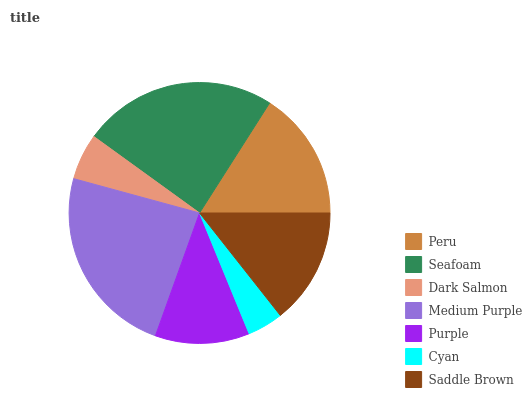Is Cyan the minimum?
Answer yes or no. Yes. Is Seafoam the maximum?
Answer yes or no. Yes. Is Dark Salmon the minimum?
Answer yes or no. No. Is Dark Salmon the maximum?
Answer yes or no. No. Is Seafoam greater than Dark Salmon?
Answer yes or no. Yes. Is Dark Salmon less than Seafoam?
Answer yes or no. Yes. Is Dark Salmon greater than Seafoam?
Answer yes or no. No. Is Seafoam less than Dark Salmon?
Answer yes or no. No. Is Saddle Brown the high median?
Answer yes or no. Yes. Is Saddle Brown the low median?
Answer yes or no. Yes. Is Cyan the high median?
Answer yes or no. No. Is Cyan the low median?
Answer yes or no. No. 